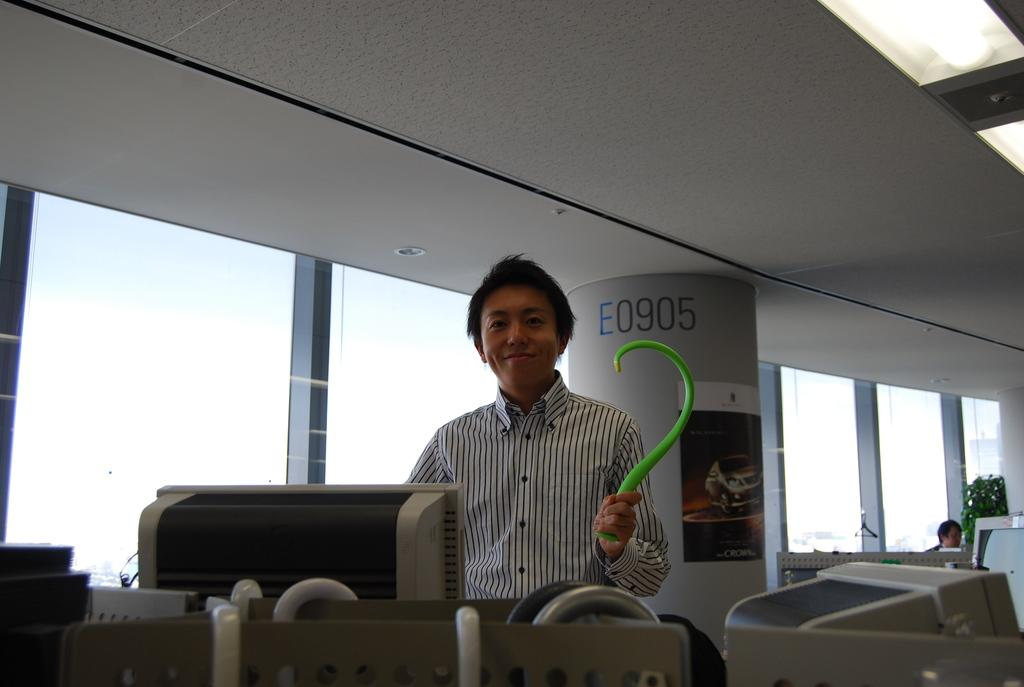Who is present in the image? There is a man in the image. What is the man wearing? The man is wearing a black and white shirt. What objects are in front of the man? There are computers in front of the man. What can be seen to the left of the man? There are glass windows to the left of the man. What is visible at the top of the image? There is a roof visible at the top of the image. What type of party is the man attending in the image? There is no indication of a party in the image; it simply shows a man with computers in front of him and glass windows to his left. 